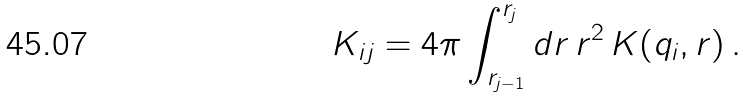Convert formula to latex. <formula><loc_0><loc_0><loc_500><loc_500>K _ { i j } = 4 \pi \int _ { r _ { j - 1 } } ^ { r _ { j } } d r \, r ^ { 2 } \, K ( q _ { i } , r ) \, .</formula> 